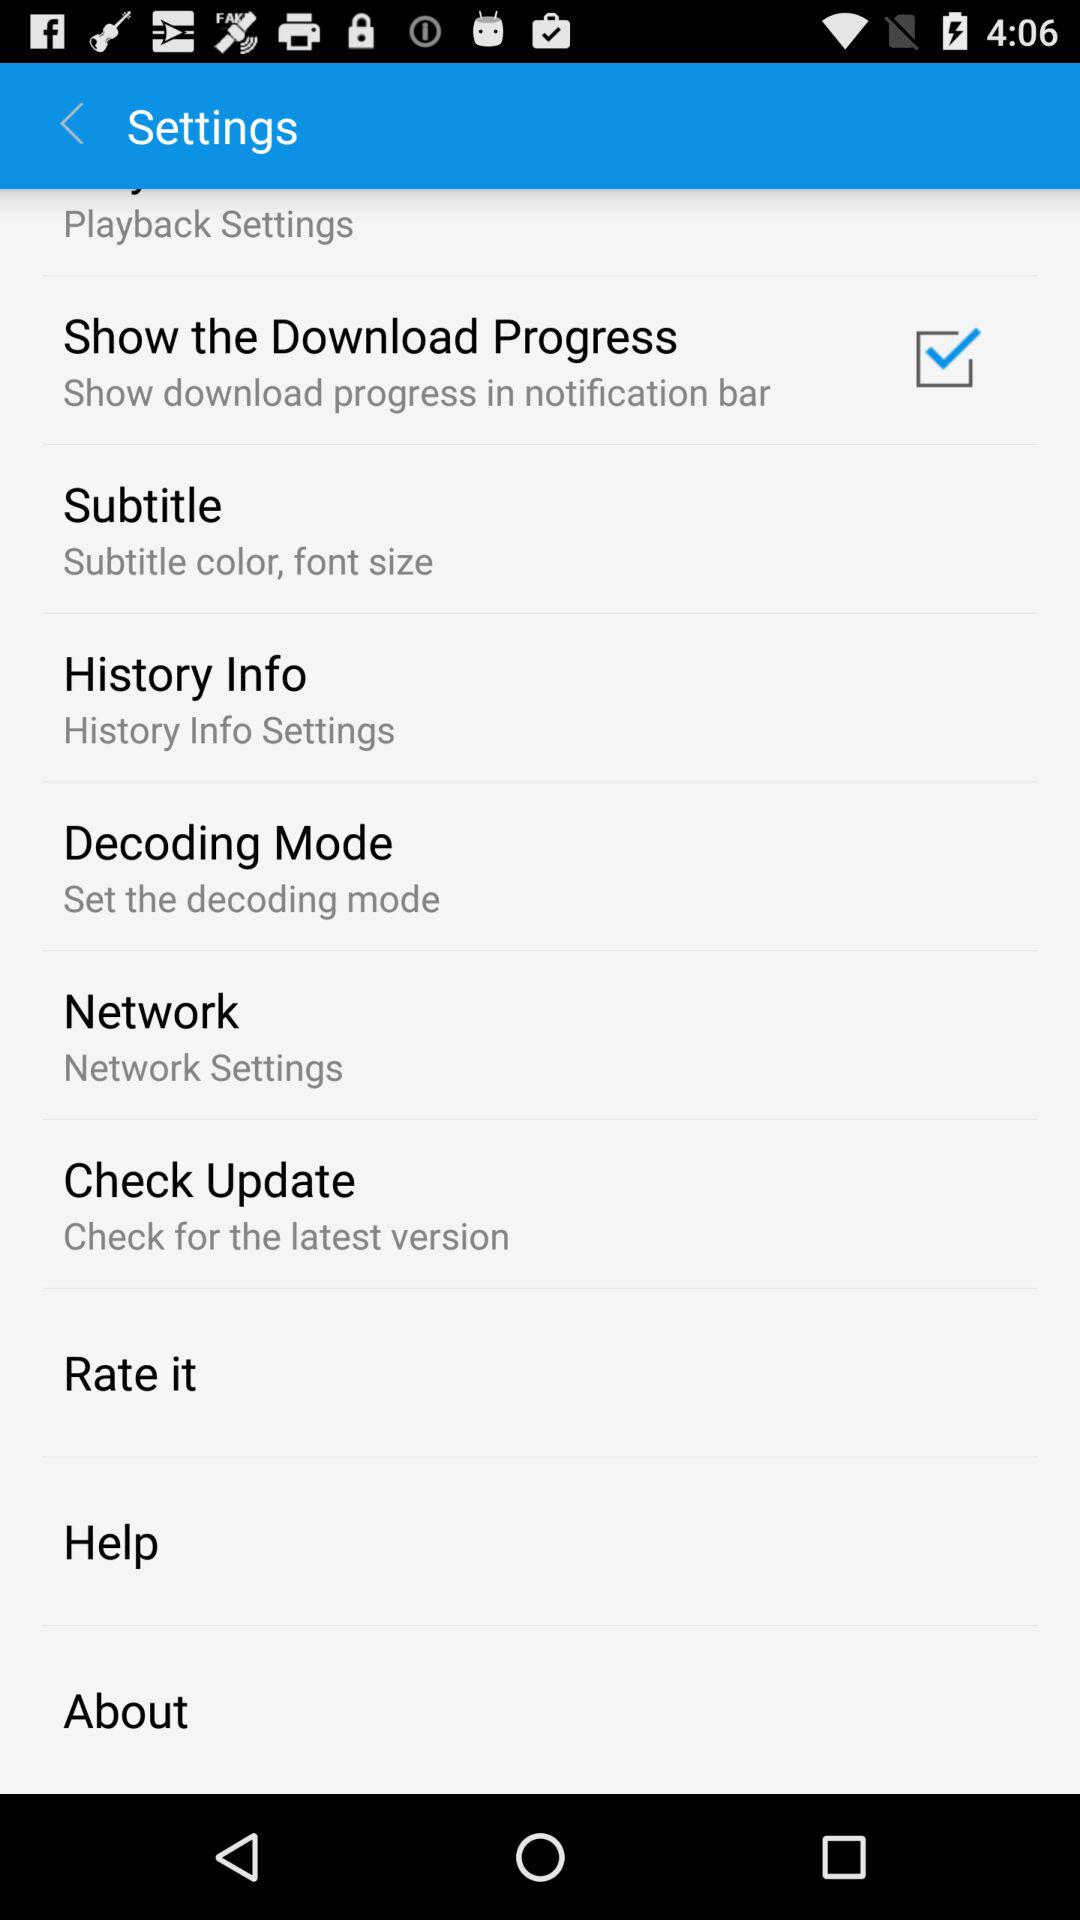What is the status of the "Show the Download Progress? The status is on. 